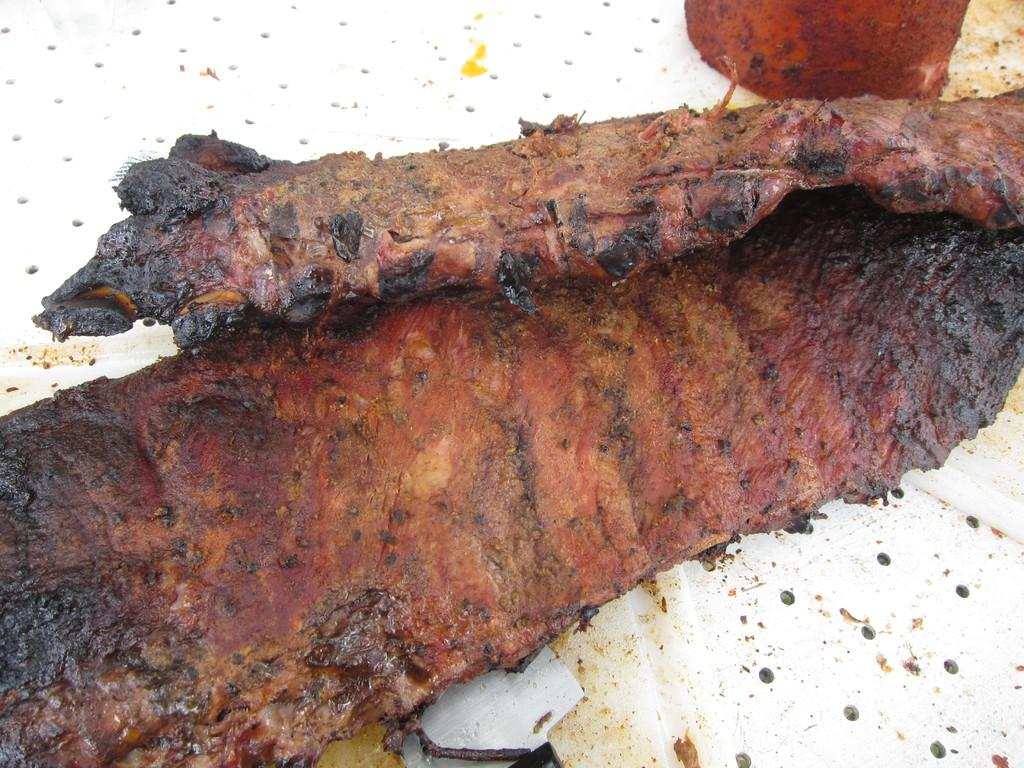What type of food is visible in the image? There is meat in the image. What else can be seen in the image besides the meat? There is a cloth in the image. What type of beast is present in the image? There is no beast present in the image; it only features meat and a cloth. Who is taking the picture of the meat and cloth in the image? There is no camera or person taking a picture in the image. 